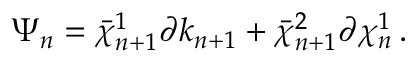<formula> <loc_0><loc_0><loc_500><loc_500>\Psi _ { n } = \bar { \chi } _ { n + 1 } ^ { 1 } \partial k _ { n + 1 } + \bar { \chi } _ { n + 1 } ^ { 2 } \partial \chi _ { n } ^ { 1 } \, .</formula> 